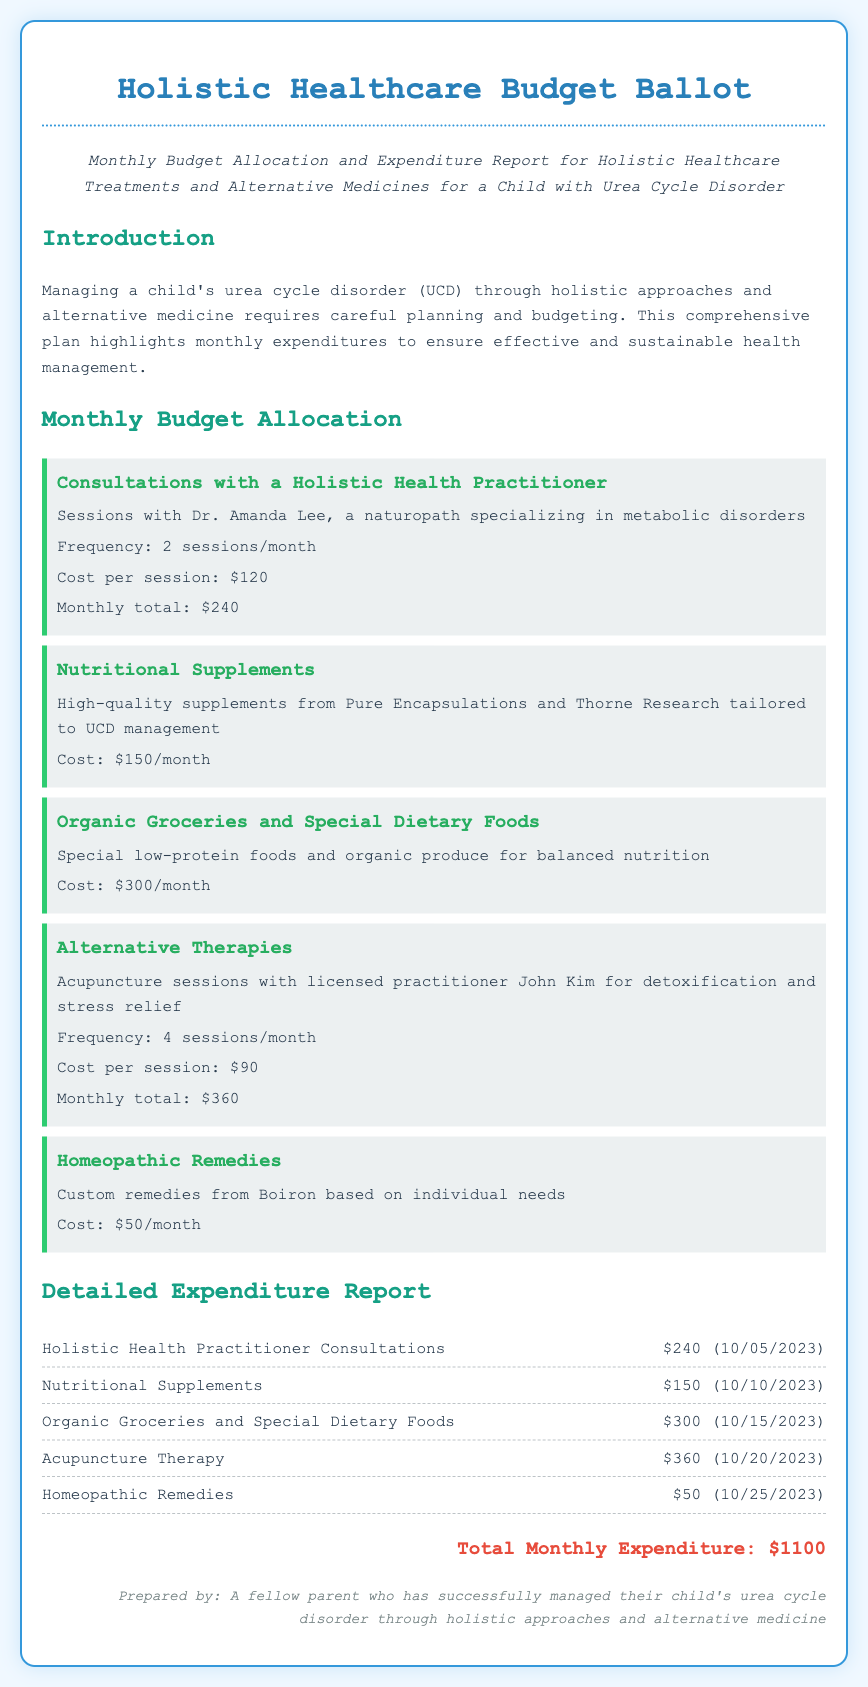What is the title of the document? The title of the document is presented at the top of the page as "Holistic Healthcare Budget Ballot."
Answer: Holistic Healthcare Budget Ballot What is the total monthly expenditure? The total monthly expenditure is summarized at the bottom of the expenditure report as "$1100."
Answer: $1100 How many sessions with the holistic health practitioner are scheduled per month? The document indicates the frequency of sessions with the holistic health practitioner as "2 sessions/month."
Answer: 2 sessions/month What is the cost of acupuncture therapy per session? The document specifies the cost of acupuncture therapy as "$90 per session."
Answer: $90 What is the monthly budget for organic groceries and special dietary foods? The document lists the budget for organic groceries and special dietary foods as "$300/month."
Answer: $300/month Who provides the nutritional supplements? The document mentions that the nutritional supplements are sourced from "Pure Encapsulations and Thorne Research."
Answer: Pure Encapsulations and Thorne Research How often are homeopathic remedies purchased? The document indicates the cost of homeopathic remedies as "$50/month," implying they are purchased monthly.
Answer: $50/month What is the name of the holistic health practitioner mentioned? The name of the holistic health practitioner specified in the document is "Dr. Amanda Lee."
Answer: Dr. Amanda Lee What date was the expenditure for nutritional supplements recorded? The document states that the expenditure for nutritional supplements was recorded on "10/10/2023."
Answer: 10/10/2023 